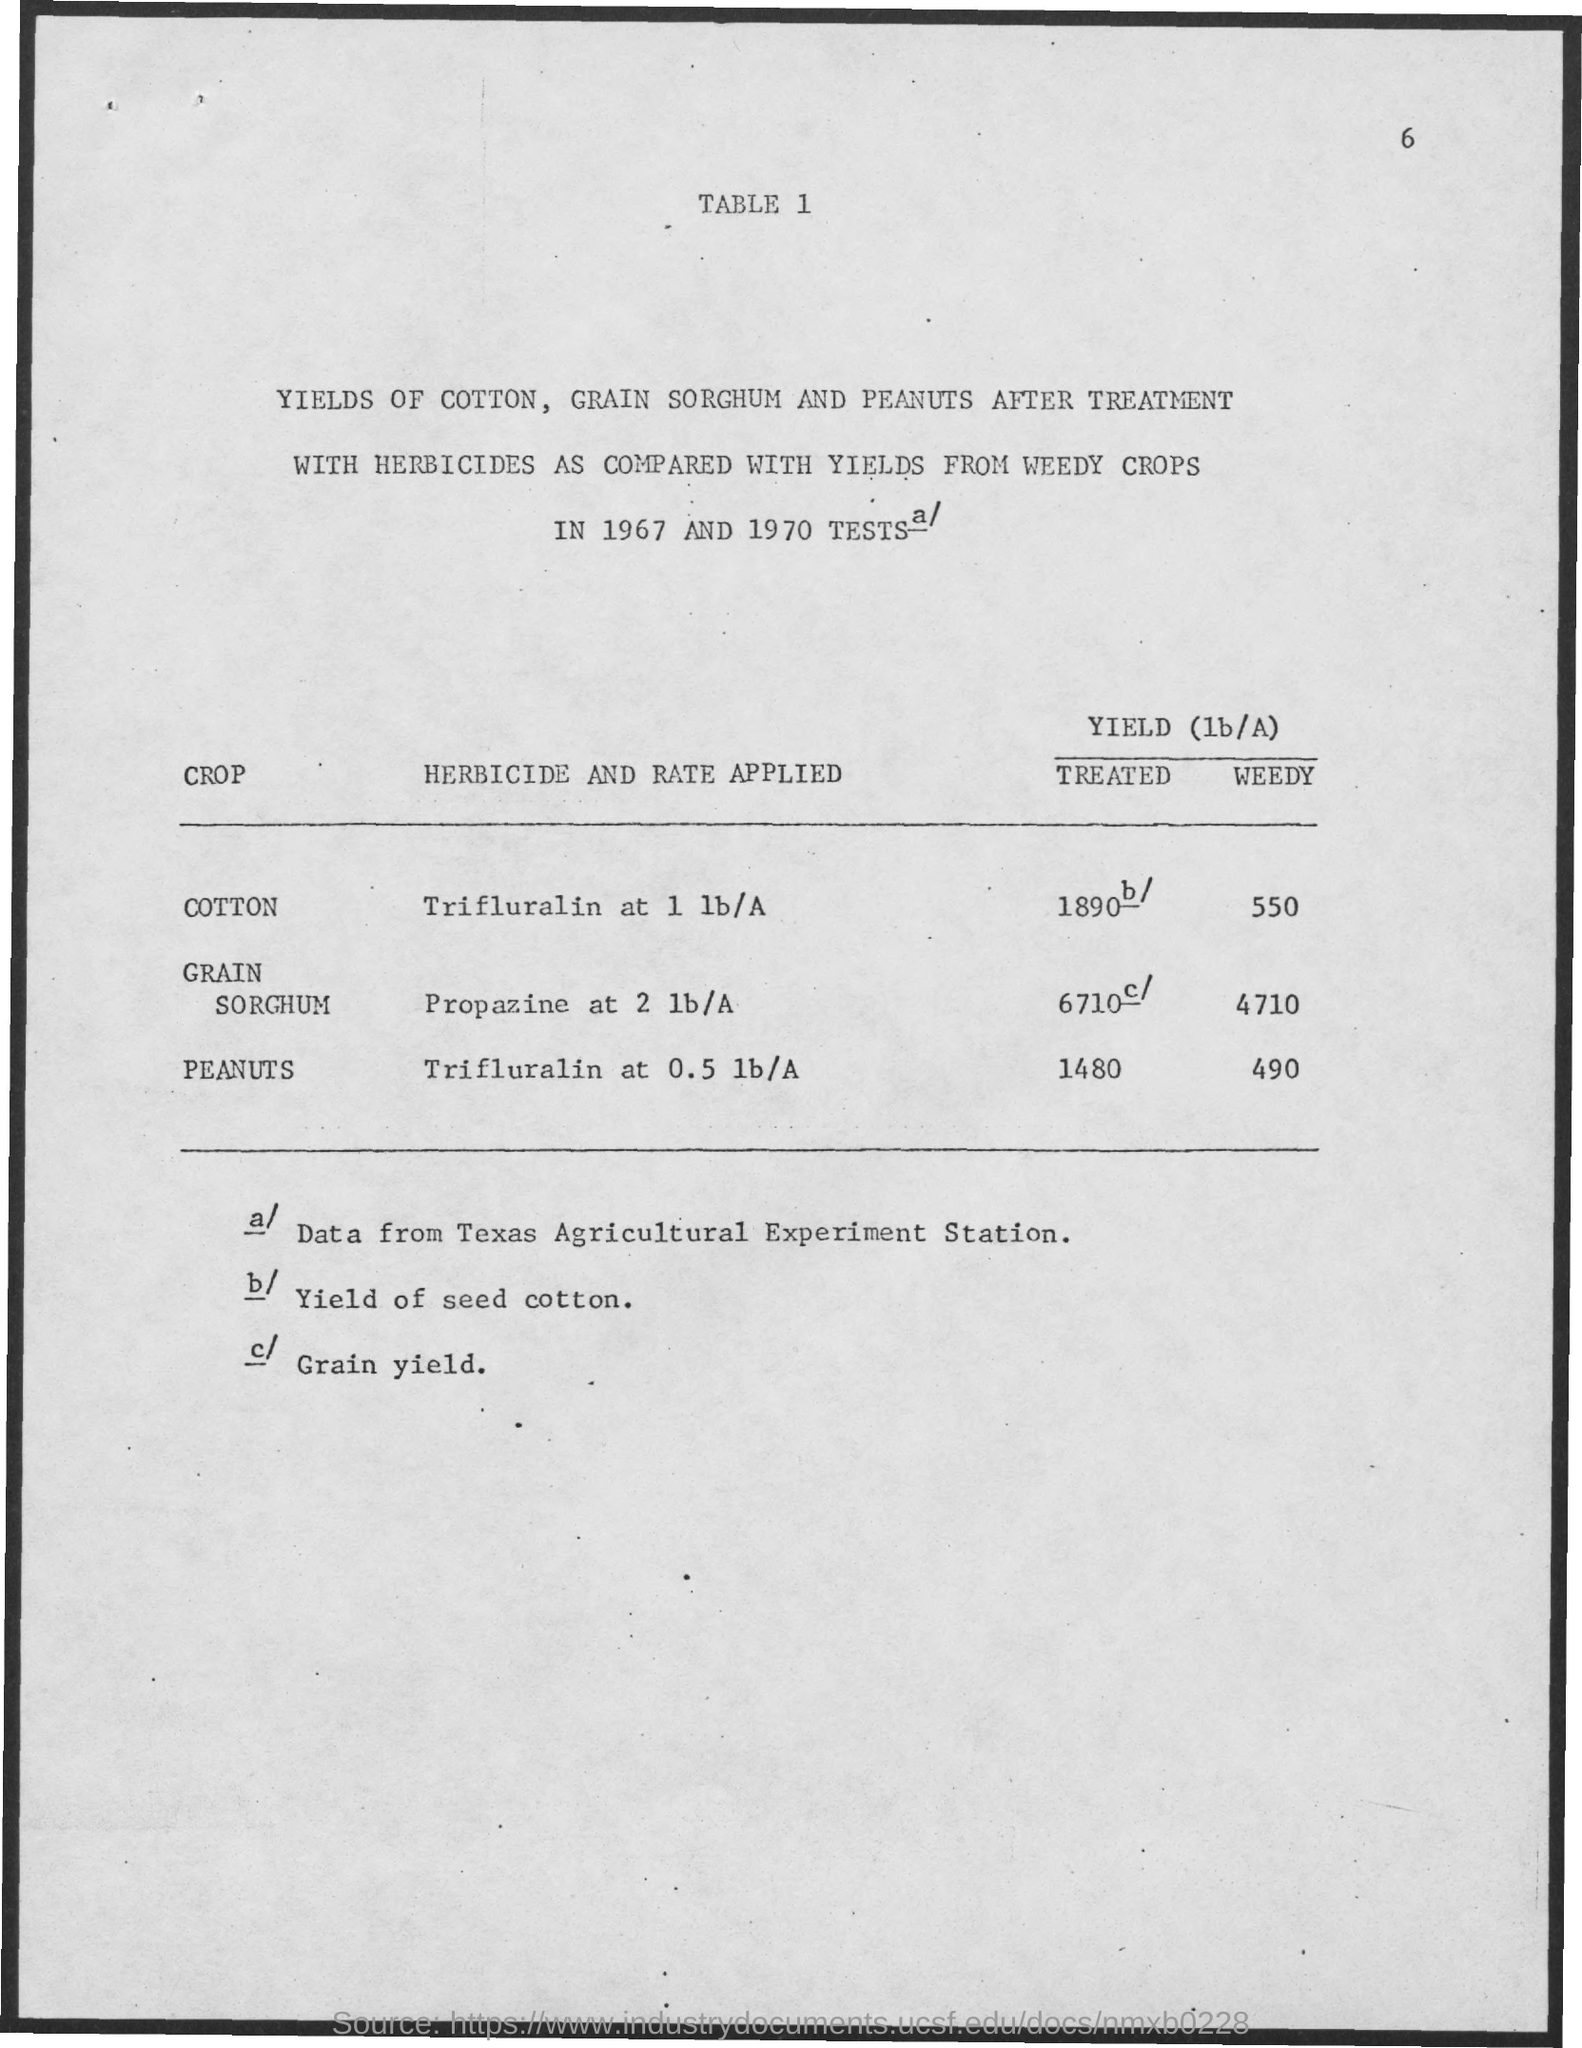What is the Herbicide and rate applied for cotton?
Offer a terse response. TRIFLURALIN AT 1 lb/A. What is the Herbicide and rate applied for Grain Sorghum?
Your answer should be compact. Propazine at 2 lb/A. What is the Herbicide and rate applied for Peanuts?
Offer a very short reply. TRIFLURALIN AT 0.5 lb/A. When were the tests held?
Offer a very short reply. 1967 and 1970. 